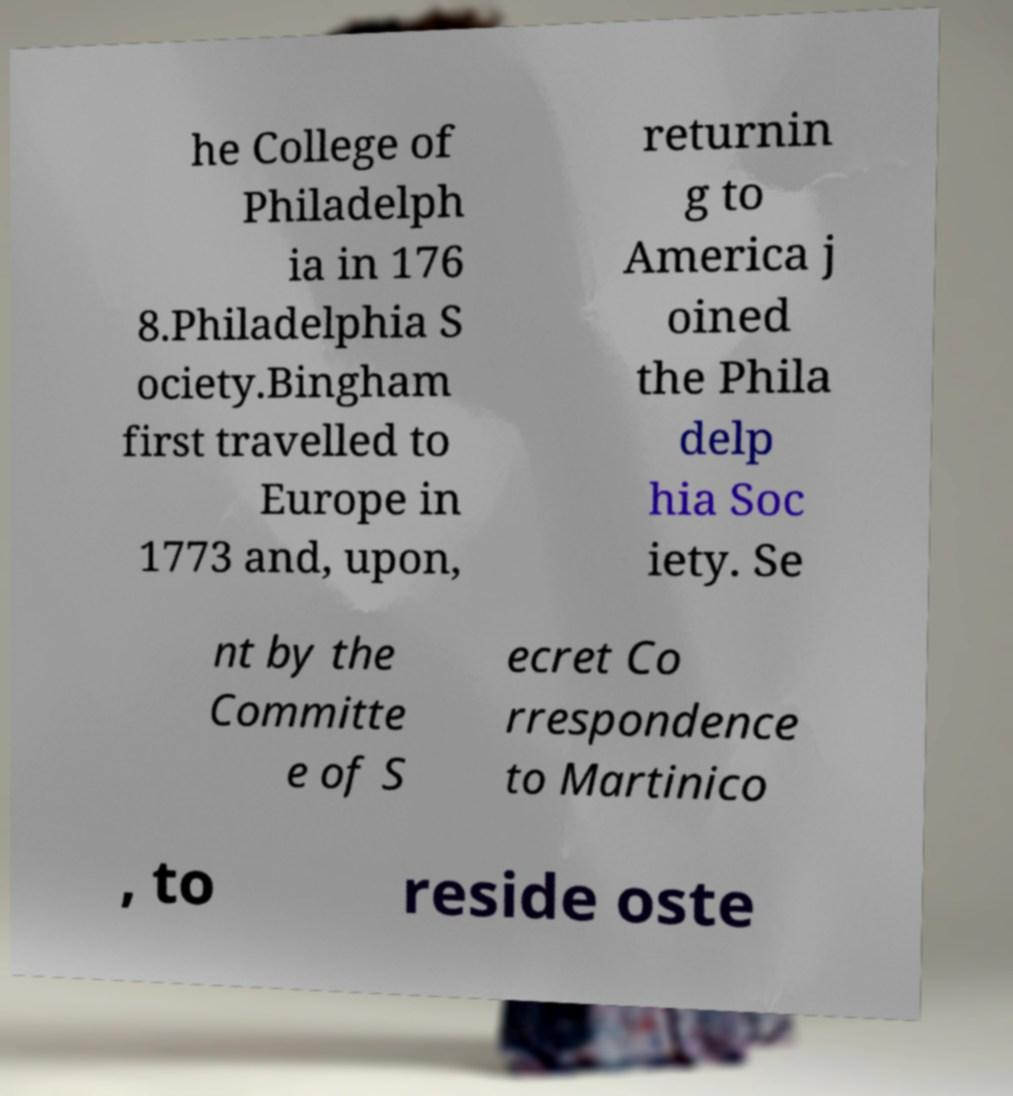For documentation purposes, I need the text within this image transcribed. Could you provide that? he College of Philadelph ia in 176 8.Philadelphia S ociety.Bingham first travelled to Europe in 1773 and, upon, returnin g to America j oined the Phila delp hia Soc iety. Se nt by the Committe e of S ecret Co rrespondence to Martinico , to reside oste 